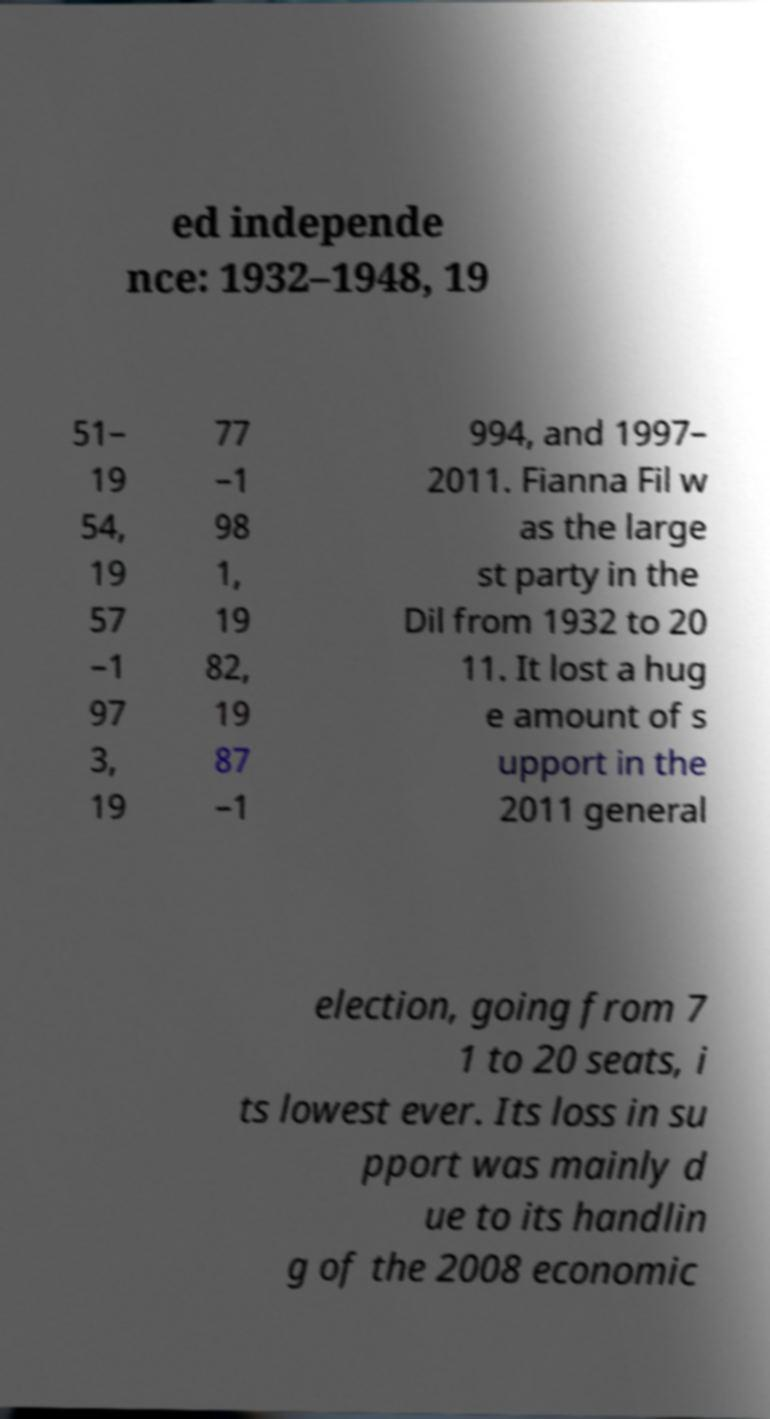Can you accurately transcribe the text from the provided image for me? ed independe nce: 1932–1948, 19 51– 19 54, 19 57 –1 97 3, 19 77 –1 98 1, 19 82, 19 87 –1 994, and 1997– 2011. Fianna Fil w as the large st party in the Dil from 1932 to 20 11. It lost a hug e amount of s upport in the 2011 general election, going from 7 1 to 20 seats, i ts lowest ever. Its loss in su pport was mainly d ue to its handlin g of the 2008 economic 